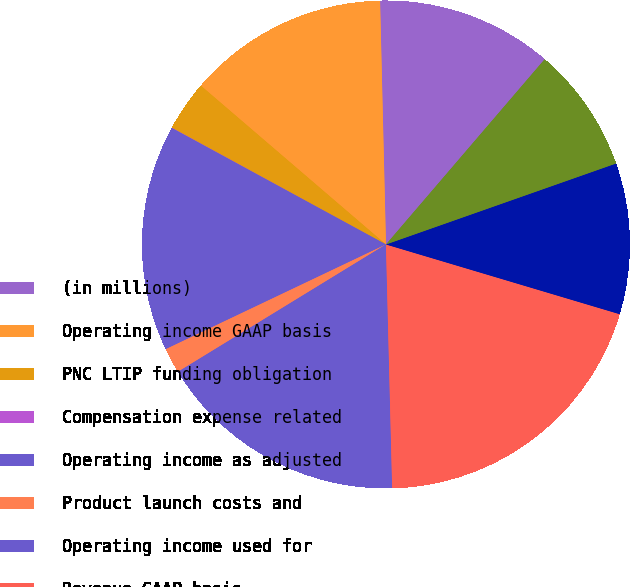Convert chart. <chart><loc_0><loc_0><loc_500><loc_500><pie_chart><fcel>(in millions)<fcel>Operating income GAAP basis<fcel>PNC LTIP funding obligation<fcel>Compensation expense related<fcel>Operating income as adjusted<fcel>Product launch costs and<fcel>Operating income used for<fcel>Revenue GAAP basis<fcel>Distribution and servicing<fcel>Amortization of deferred sales<nl><fcel>11.66%<fcel>13.33%<fcel>3.34%<fcel>0.02%<fcel>14.99%<fcel>1.68%<fcel>16.66%<fcel>19.98%<fcel>10.0%<fcel>8.34%<nl></chart> 